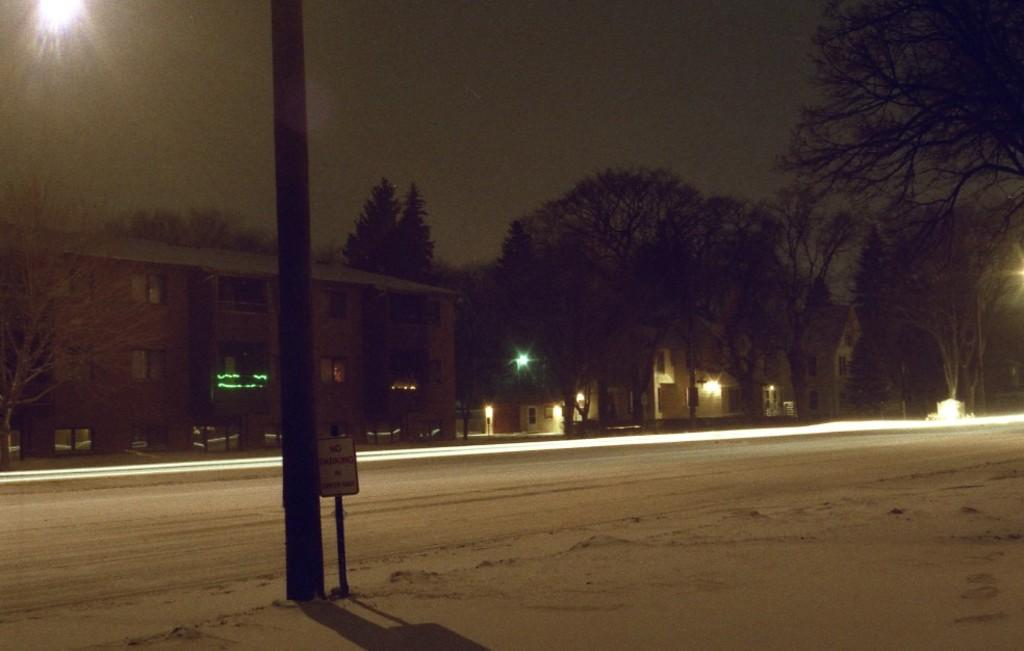What is the main feature of the image? There is a road in the image. What else can be seen in the image besides the road? There is a pole, a board with a pole, trees, lights, buildings, and the sky visible in the image. Can you describe the pole in the image? There is a pole in the image, and there is also a board with a pole. What is visible in the background of the image? In the background of the image, there are trees, lights, and buildings. What part of the natural environment is visible in the image? The sky is visible in the image. What type of wool is being used to create the humor in the image? There is no wool or humor present in the image. Can you provide a suggestion for improving the lighting in the image? The image is a static representation and cannot be altered, so it is not possible to provide a suggestion for improving the lighting. 